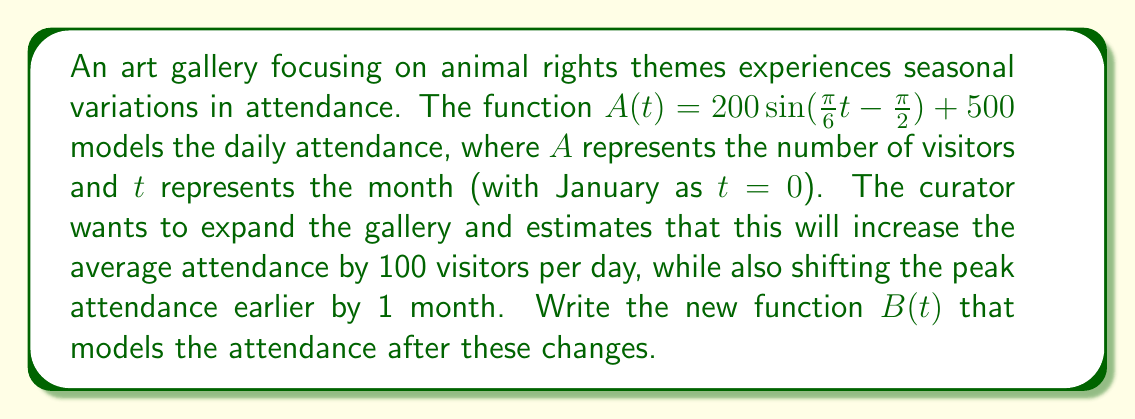Can you solve this math problem? To transform the given function $A(t)$ into the new function $B(t)$, we need to apply several transformations:

1. Vertical shift: Increasing the average attendance by 100 visitors means we need to add 100 to the function.

2. Horizontal shift: Shifting the peak attendance earlier by 1 month means we need to replace $t$ with $(t+1)$ in the sine function.

3. The amplitude and period of the function remain unchanged.

Let's apply these transformations step by step:

1. Start with the original function:
   $A(t) = 200 \sin(\frac{\pi}{6}t - \frac{\pi}{2}) + 500$

2. Add 100 to account for the increased average attendance:
   $B(t) = 200 \sin(\frac{\pi}{6}t - \frac{\pi}{2}) + 600$

3. Replace $t$ with $(t+1)$ inside the sine function to shift the peak earlier by 1 month:
   $B(t) = 200 \sin(\frac{\pi}{6}(t+1) - \frac{\pi}{2}) + 600$

4. Simplify the expression inside the sine function:
   $\frac{\pi}{6}(t+1) - \frac{\pi}{2} = \frac{\pi}{6}t + \frac{\pi}{6} - \frac{\pi}{2} = \frac{\pi}{6}t - \frac{\pi}{3}$

Therefore, the final transformed function is:
$B(t) = 200 \sin(\frac{\pi}{6}t - \frac{\pi}{3}) + 600$
Answer: $B(t) = 200 \sin(\frac{\pi}{6}t - \frac{\pi}{3}) + 600$ 